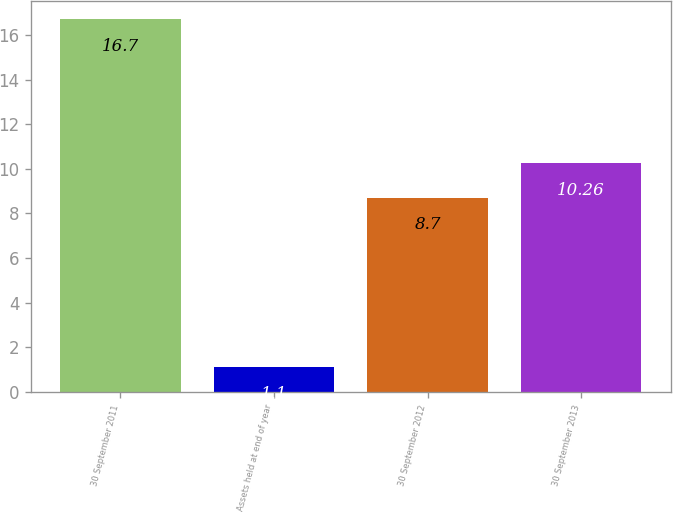Convert chart. <chart><loc_0><loc_0><loc_500><loc_500><bar_chart><fcel>30 September 2011<fcel>Assets held at end of year<fcel>30 September 2012<fcel>30 September 2013<nl><fcel>16.7<fcel>1.1<fcel>8.7<fcel>10.26<nl></chart> 